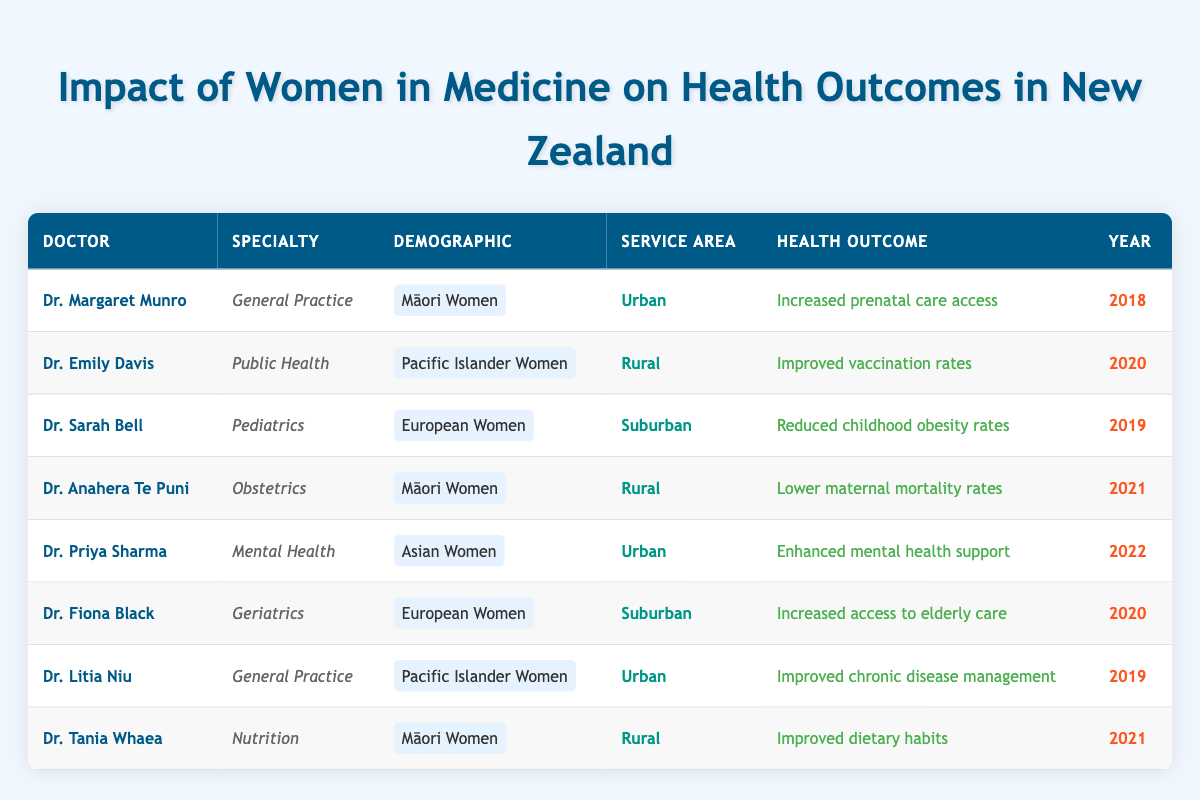What year did Dr. Priya Sharma contribute to mental health for Asian women? From the table, we can find the row for Dr. Priya Sharma. It states that she contributed to enhanced mental health support for Asian women in the year 2022.
Answer: 2022 How many health outcomes listed in the table relate to Māori women? By examining the demographic column, we notice that there are three entries for Māori women: increased prenatal care access by Dr. Margaret Munro, lower maternal mortality rates by Dr. Anahera Te Puni, and improved dietary habits by Dr. Tania Whaea. Therefore, the total count is three.
Answer: 3 Did any doctors focus on improving vaccination rates for European women? Looking through the health outcomes, only Dr. Emily Davis worked on improved vaccination rates, but she focused on Pacific Islander women, not European women. Thus, the statement is false.
Answer: No Which health outcome for Māori women was achieved by Dr. Anahera Te Puni? Checking the table, we locate Dr. Anahera Te Puni, who is listed as having contributed to lower maternal mortality rates for Māori women in 2021.
Answer: Lower maternal mortality rates What is the average year of contribution to health outcomes by the doctors listed in the table? We need to add the years from each entry and then divide by the number of entries. The years are 2018, 2020, 2019, 2021, 2022, 2020, 2019, and 2021, which sum up to 2018 + 2020 + 2019 + 2021 + 2022 + 2020 + 2019 + 2021 = 1619. Since there are 8 entries, the average is 1619/8 = 202.375. Rounding gives us 202.
Answer: 202.4 Which demographic received improved chronic disease management according to the table? Dr. Litia Niu's entry specifies that she provided improved chronic disease management for Pacific Islander women in an urban service area. Thus, this is the demographic we are looking for.
Answer: Pacific Islander Women What is the specialty of the doctor who worked on reducing childhood obesity rates? Dr. Sarah Bell is associated with pediatric care, as indicated in the table. She contributed to reducing childhood obesity rates for European women in 2019. Thus, her specialty is Pediatrics.
Answer: Pediatrics 